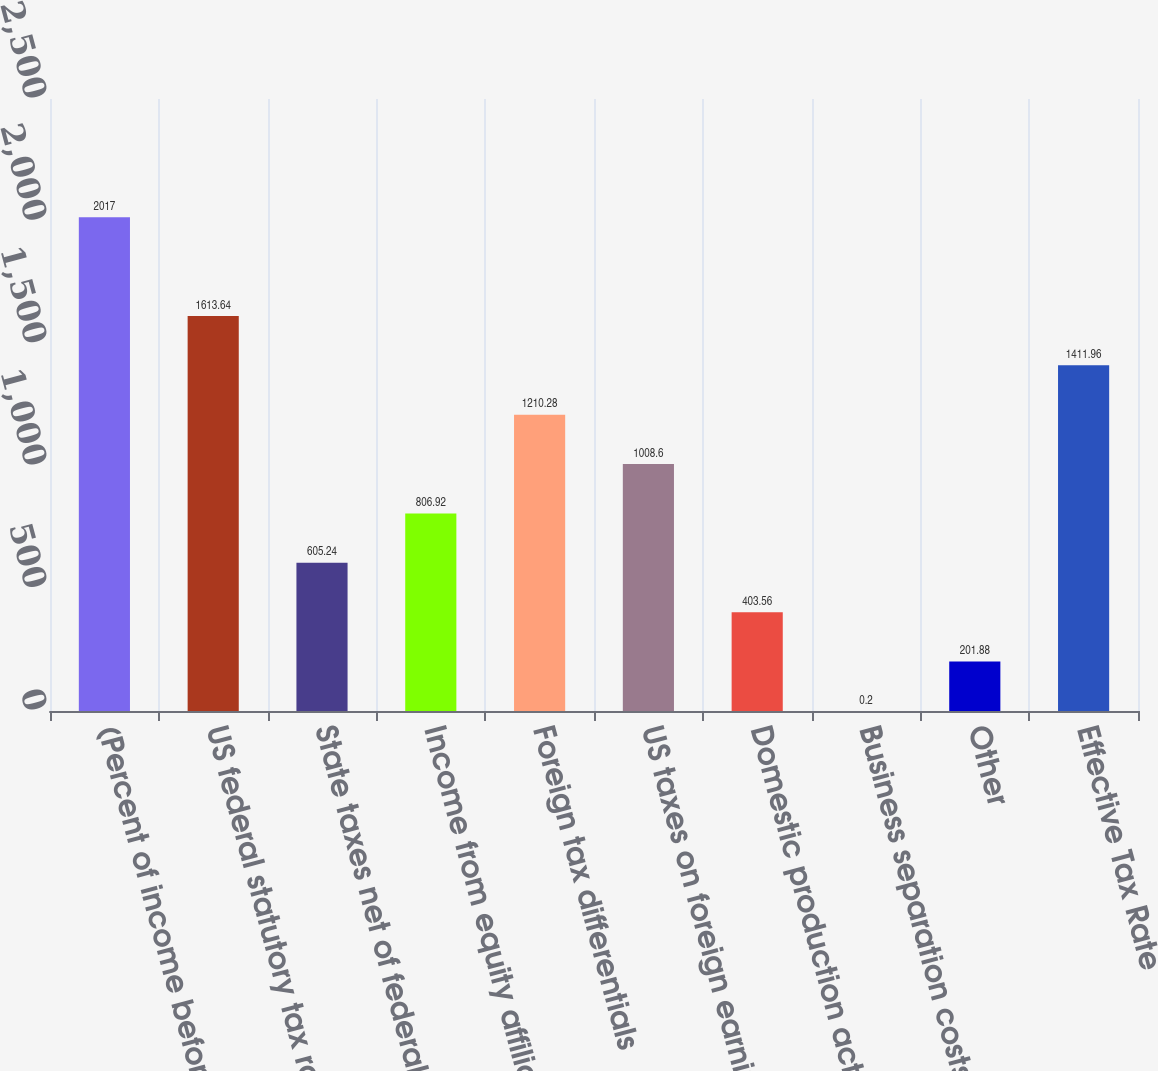Convert chart to OTSL. <chart><loc_0><loc_0><loc_500><loc_500><bar_chart><fcel>(Percent of income before<fcel>US federal statutory tax rate<fcel>State taxes net of federal<fcel>Income from equity affiliates<fcel>Foreign tax differentials<fcel>US taxes on foreign earnings<fcel>Domestic production activities<fcel>Business separation costs<fcel>Other<fcel>Effective Tax Rate<nl><fcel>2017<fcel>1613.64<fcel>605.24<fcel>806.92<fcel>1210.28<fcel>1008.6<fcel>403.56<fcel>0.2<fcel>201.88<fcel>1411.96<nl></chart> 